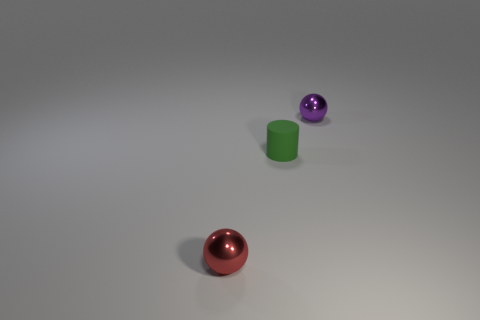Subtract all purple balls. How many balls are left? 1 Subtract 1 cylinders. How many cylinders are left? 0 Subtract all cylinders. How many objects are left? 2 Add 2 tiny red matte objects. How many tiny red matte objects exist? 2 Add 2 green matte cubes. How many objects exist? 5 Subtract 0 gray blocks. How many objects are left? 3 Subtract all yellow cylinders. Subtract all brown blocks. How many cylinders are left? 1 Subtract all red blocks. How many red spheres are left? 1 Subtract all tiny purple shiny spheres. Subtract all cylinders. How many objects are left? 1 Add 1 red things. How many red things are left? 2 